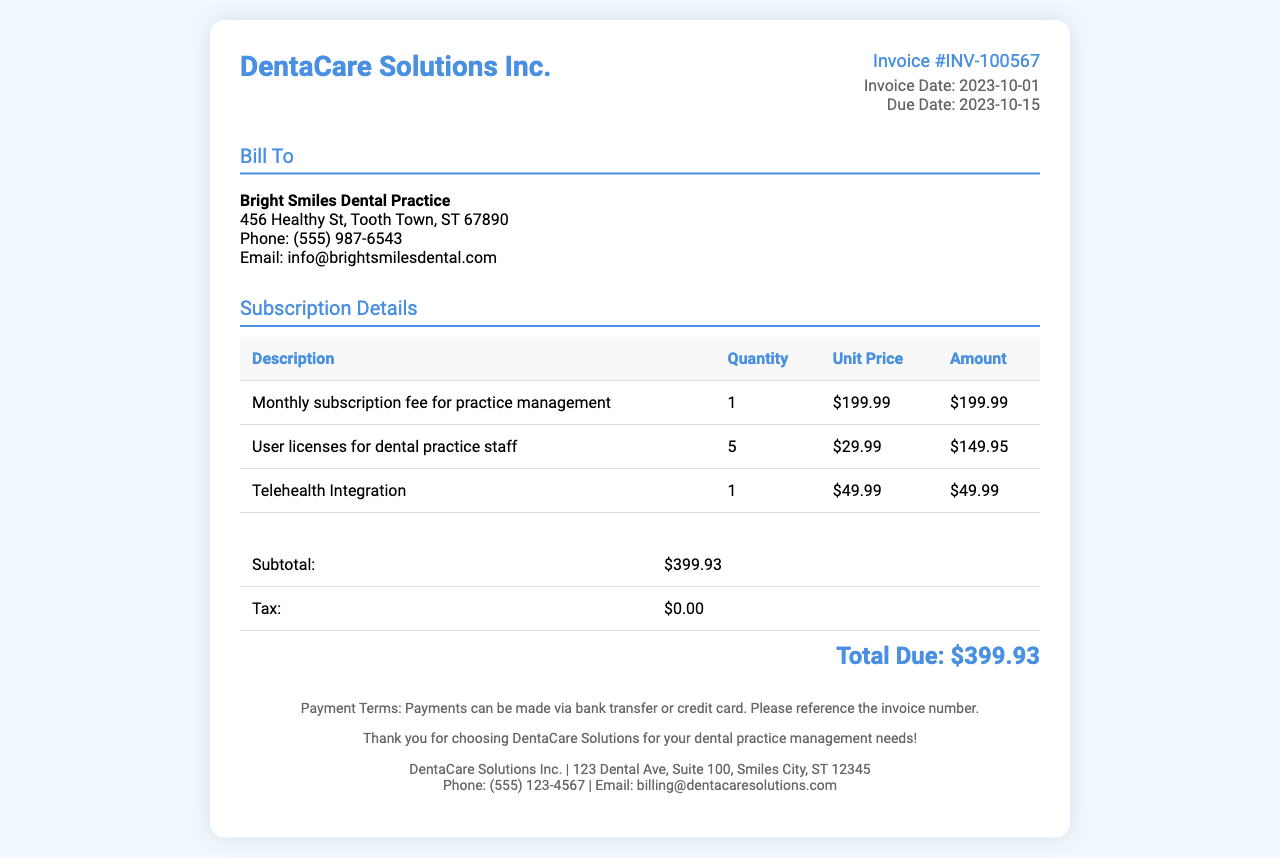What is the invoice number? The invoice number is a unique identifier for this bill, found in the header section.
Answer: INV-100567 What is the total due amount? The total due is displayed at the end of the invoice summary section.
Answer: $399.93 How many user licenses are billed? The quantity of user licenses is stated in the subscription details table.
Answer: 5 What is the monthly subscription fee for practice management? The unit price for the monthly subscription is found in the subscription details table.
Answer: $199.99 What is the due date for the invoice? The due date is shown in the invoice details section.
Answer: 2023-10-15 What is the subtotal amount? The subtotal is the sum of the amounts before tax, located in the summary section.
Answer: $399.93 Is there any tax applied to this invoice? The tax information can be found in the summary section underneath the subtotal.
Answer: $0.00 What additional feature is billed on this invoice? The additional feature included in the subscription details is listed in the table.
Answer: Telehealth Integration 